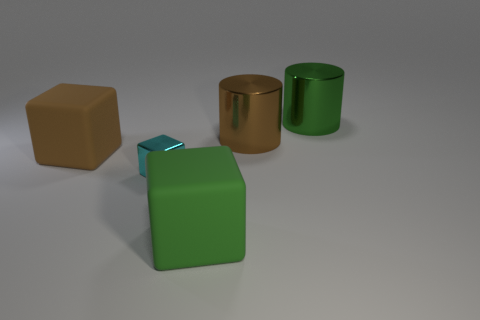Can you tell me what the brown object to the left is made of? The brown object appears to be a cube with a texture reminiscent of matte plastic or wood. However, without additional information, it's challenging to ascertain the exact material definitively. 